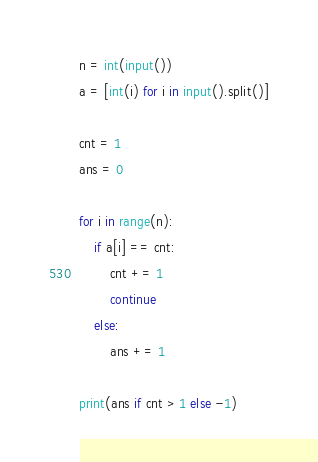<code> <loc_0><loc_0><loc_500><loc_500><_Python_>n = int(input())
a = [int(i) for i in input().split()]

cnt = 1
ans = 0

for i in range(n):
    if a[i] == cnt:
        cnt += 1
        continue
    else:
        ans += 1

print(ans if cnt > 1 else -1)
</code> 